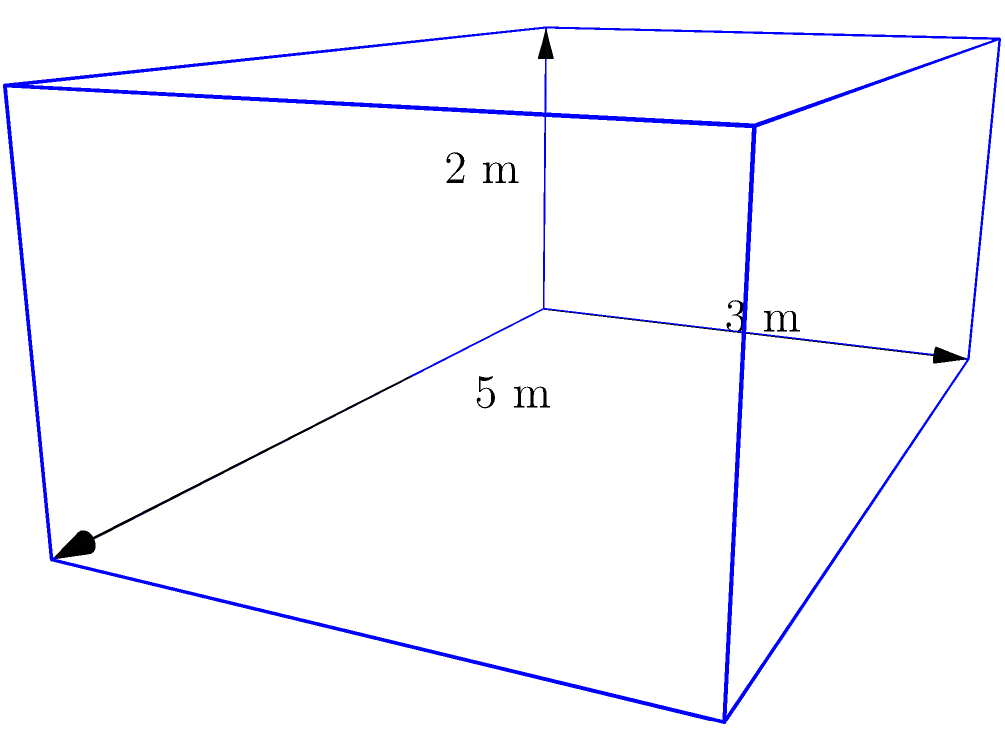During the Reconstruction era, a historic courthouse was rebuilt in a Southern state. The main structure can be approximated as a rectangular prism with dimensions 5 meters in length, 3 meters in width, and 2 meters in height. What is the volume of this reconstructed courthouse in cubic meters? To calculate the volume of a rectangular prism, we need to multiply its length, width, and height.

Given dimensions:
- Length (l) = 5 meters
- Width (w) = 3 meters
- Height (h) = 2 meters

The formula for the volume of a rectangular prism is:

$$V = l \times w \times h$$

Substituting the values:

$$V = 5 \text{ m} \times 3 \text{ m} \times 2 \text{ m}$$

$$V = 30 \text{ m}^3$$

Therefore, the volume of the reconstructed courthouse is 30 cubic meters.
Answer: 30 m³ 